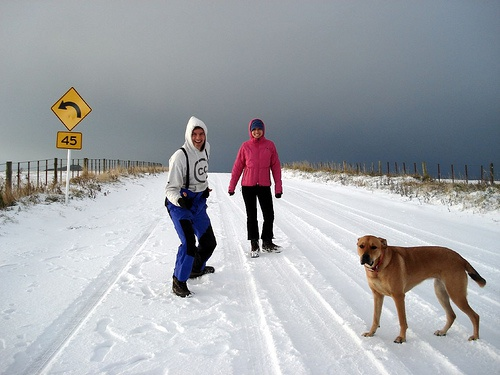Describe the objects in this image and their specific colors. I can see people in darkgray, black, navy, and lightgray tones, dog in darkgray, maroon, black, and gray tones, and people in darkgray, black, brown, and maroon tones in this image. 